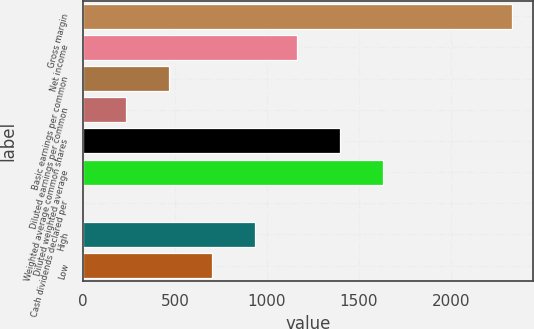<chart> <loc_0><loc_0><loc_500><loc_500><bar_chart><fcel>Gross margin<fcel>Net income<fcel>Basic earnings per common<fcel>Diluted earnings per common<fcel>Weighted average common shares<fcel>Diluted weighted average<fcel>Cash dividends declared per<fcel>High<fcel>Low<nl><fcel>2331.4<fcel>1165.83<fcel>466.47<fcel>233.35<fcel>1398.95<fcel>1632.07<fcel>0.23<fcel>932.71<fcel>699.59<nl></chart> 